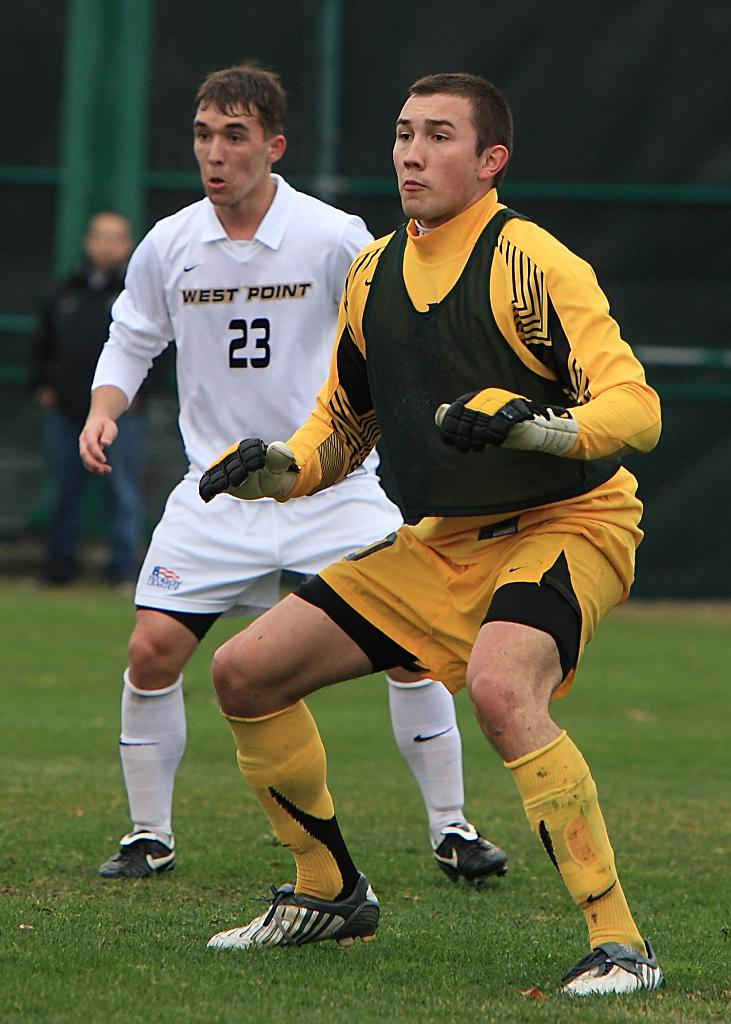How many people are in the image? There are people in the image, but the exact number is not specified. What are the people wearing? The people are wearing sports dress. Can you describe any specific accessory one person is wearing? One person is wearing gloves. What can be seen in the background of the image? There are rods in the background of the image. What is visible at the bottom of the image? There is ground visible at the bottom of the image. What type of books can be seen in the library in the image? There is no library present in the image, so it is not possible to determine what type of books might be seen. 